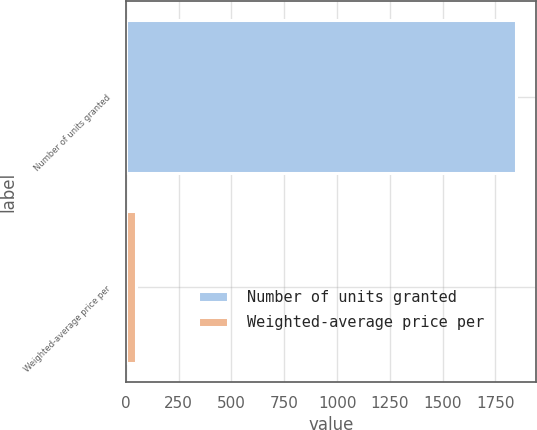Convert chart. <chart><loc_0><loc_0><loc_500><loc_500><bar_chart><fcel>Number of units granted<fcel>Weighted-average price per<nl><fcel>1848.2<fcel>46.14<nl></chart> 